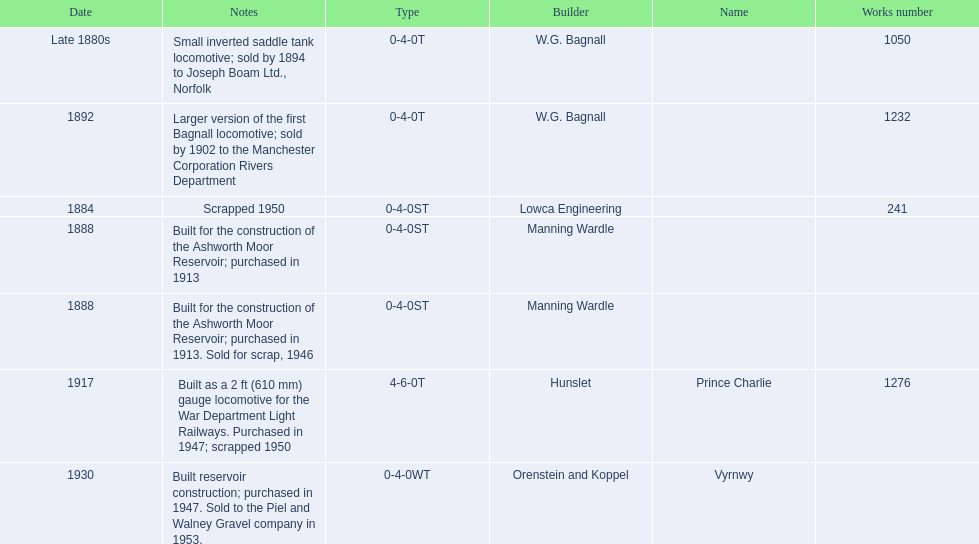Which locomotive builder built a locomotive after 1888 and built the locomotive as a 2ft gauge locomotive? Hunslet. 